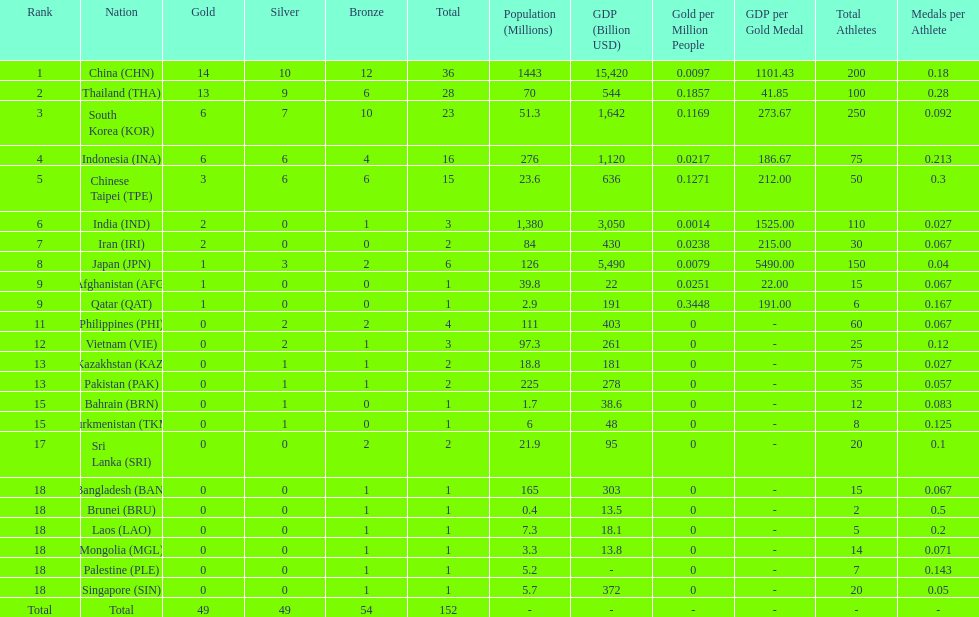What was the number of medals earned by indonesia (ina) ? 16. 